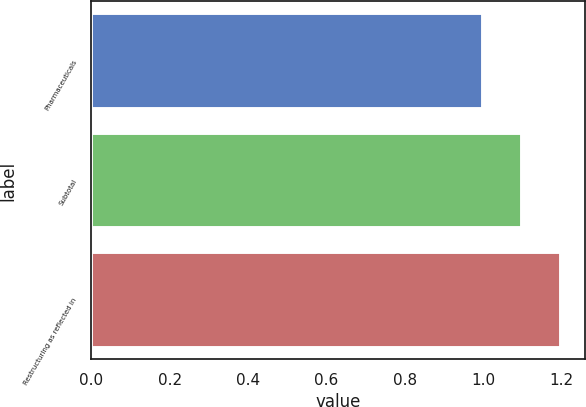Convert chart to OTSL. <chart><loc_0><loc_0><loc_500><loc_500><bar_chart><fcel>Pharmaceuticals<fcel>Subtotal<fcel>Restructuring as reflected in<nl><fcel>1<fcel>1.1<fcel>1.2<nl></chart> 